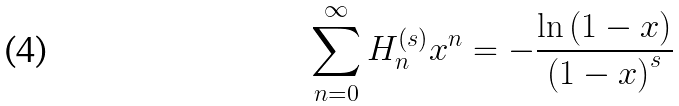Convert formula to latex. <formula><loc_0><loc_0><loc_500><loc_500>\sum _ { n = 0 } ^ { \infty } H _ { n } ^ { \left ( s \right ) } x ^ { n } = - \frac { \ln \left ( 1 - x \right ) } { \left ( 1 - x \right ) ^ { s } }</formula> 